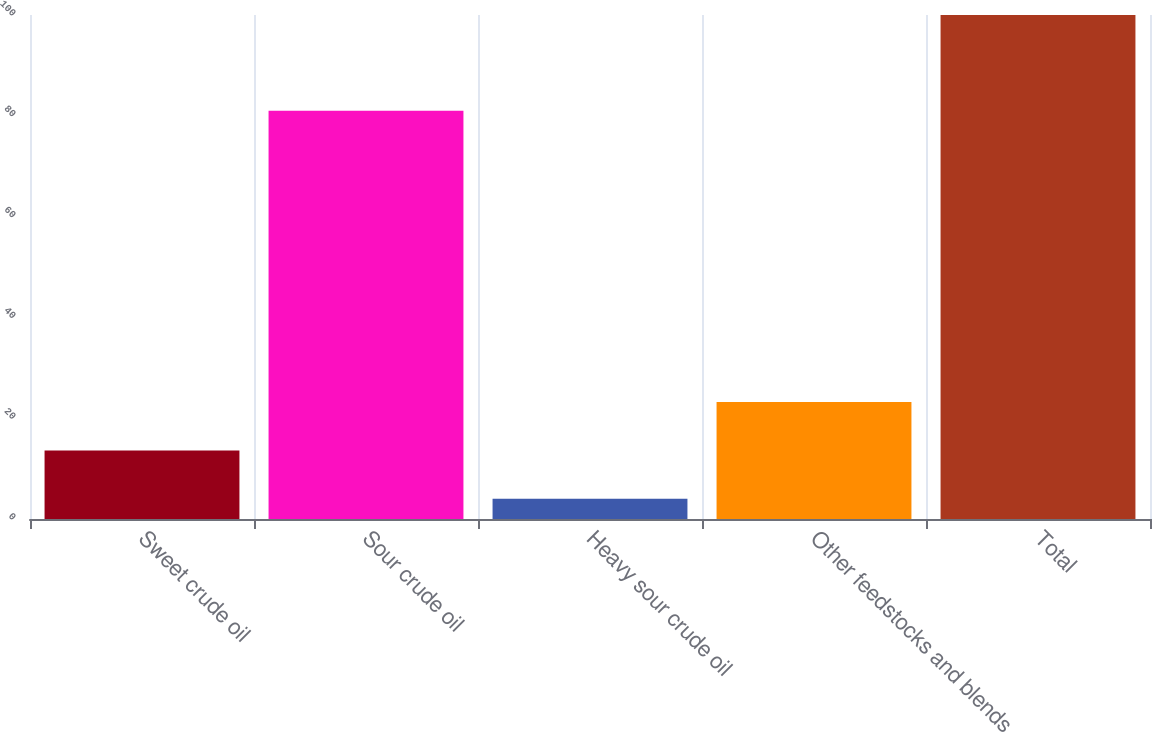Convert chart to OTSL. <chart><loc_0><loc_0><loc_500><loc_500><bar_chart><fcel>Sweet crude oil<fcel>Sour crude oil<fcel>Heavy sour crude oil<fcel>Other feedstocks and blends<fcel>Total<nl><fcel>13.6<fcel>81<fcel>4<fcel>23.2<fcel>100<nl></chart> 